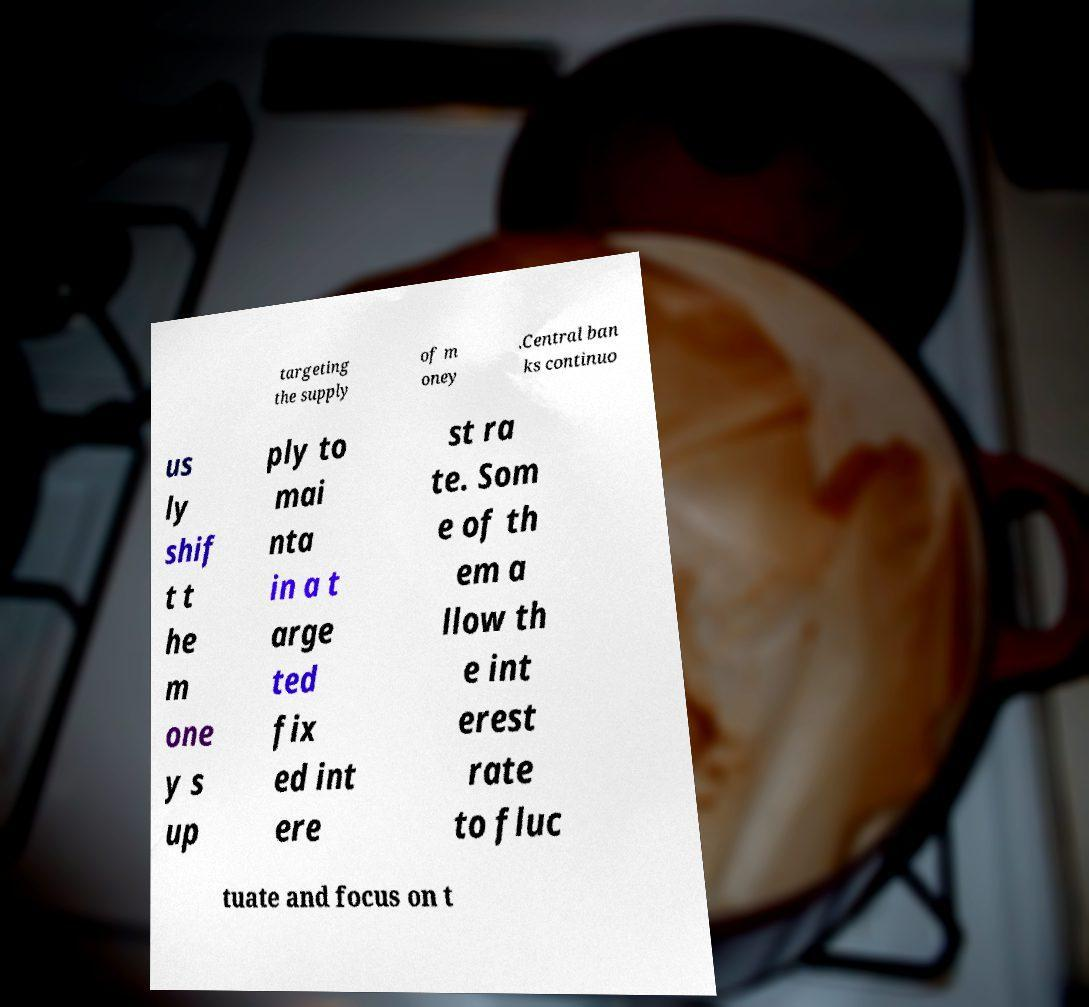For documentation purposes, I need the text within this image transcribed. Could you provide that? targeting the supply of m oney .Central ban ks continuo us ly shif t t he m one y s up ply to mai nta in a t arge ted fix ed int ere st ra te. Som e of th em a llow th e int erest rate to fluc tuate and focus on t 